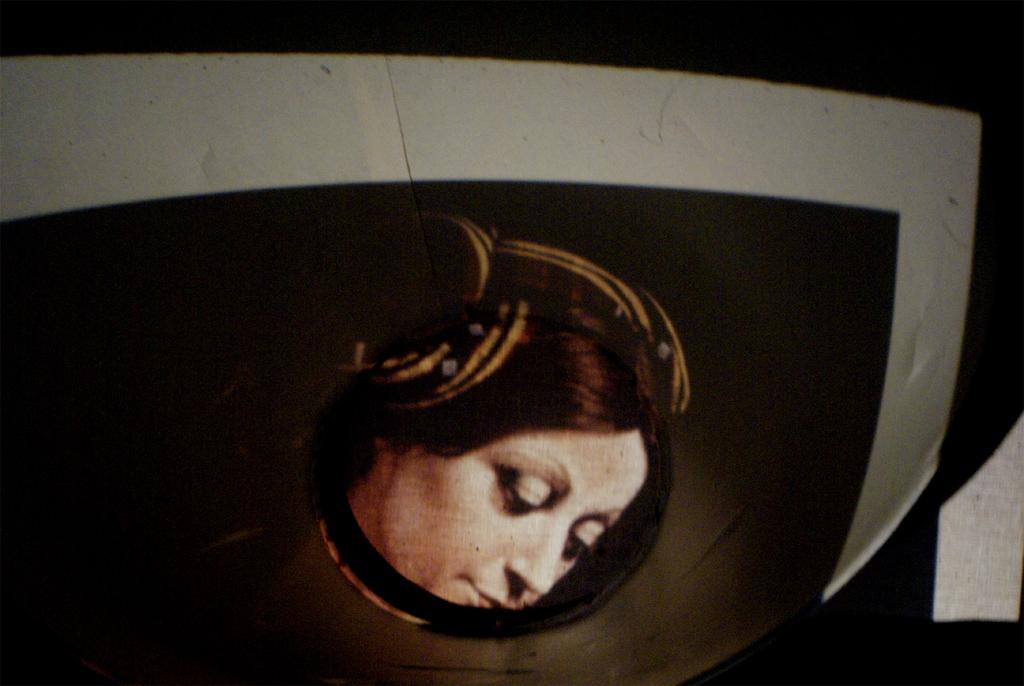What is the main subject of the image? There is a picture of a person in the image. What is the picture placed on? The picture is on a black object. What type of silver is the person holding in the image? There is no silver or any object being held by the person in the image. 